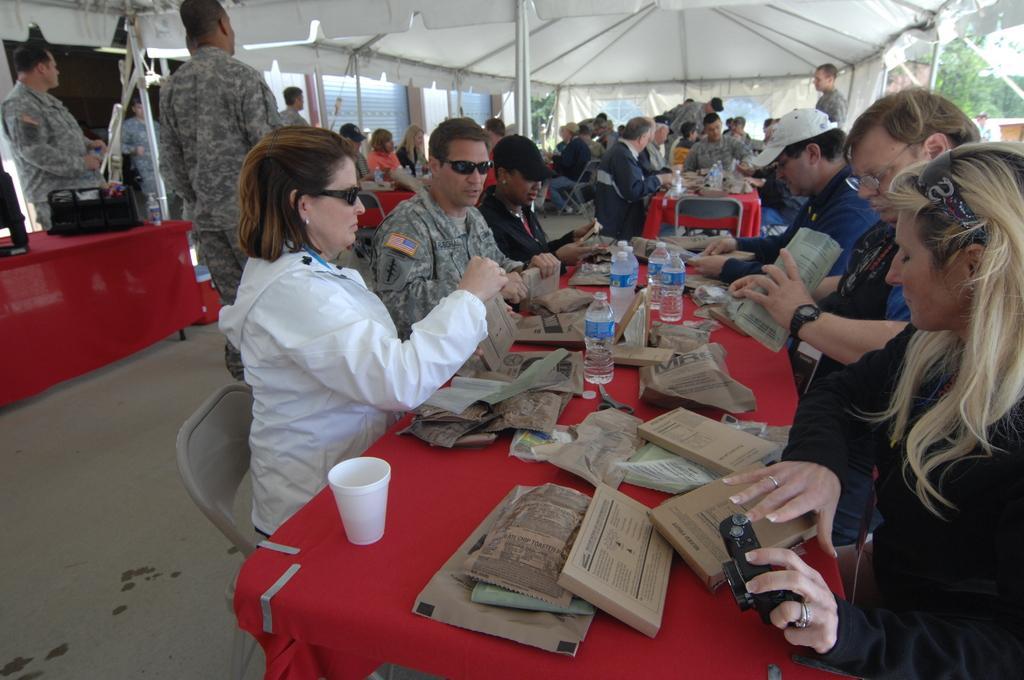How would you summarize this image in a sentence or two? This picture describes about group of people, they are all in the tent, few are seated on the chairs and few are standing, in front of them we can see few cups, bottles, covers and other things on the tables, and we can see few people wore spectacles and caps, in the background we can find few trees. 